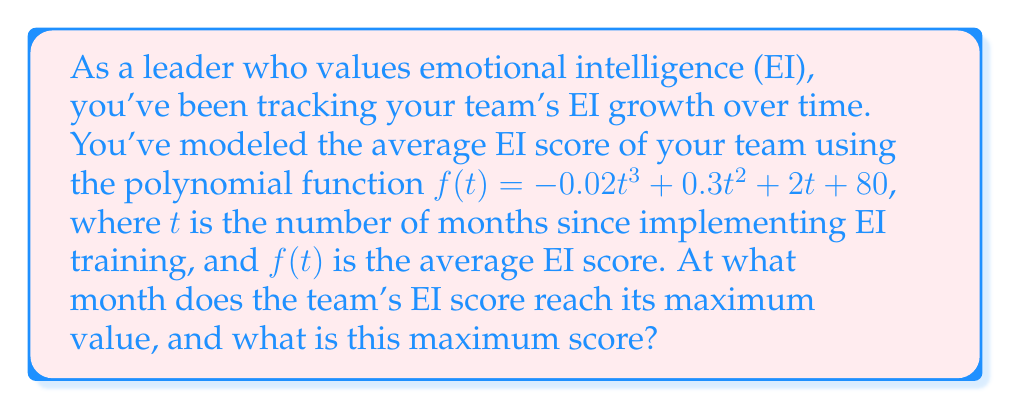Help me with this question. To find the maximum value of the function, we need to follow these steps:

1) First, we need to find the derivative of the function:
   $$f'(t) = -0.06t^2 + 0.6t + 2$$

2) To find the critical points, we set the derivative equal to zero and solve:
   $$-0.06t^2 + 0.6t + 2 = 0$$

3) This is a quadratic equation. We can solve it using the quadratic formula:
   $$t = \frac{-b \pm \sqrt{b^2 - 4ac}}{2a}$$
   where $a = -0.06$, $b = 0.6$, and $c = 2$

4) Plugging in these values:
   $$t = \frac{-0.6 \pm \sqrt{0.6^2 - 4(-0.06)(2)}}{2(-0.06)}$$
   $$= \frac{-0.6 \pm \sqrt{0.36 + 0.48}}{-0.12}$$
   $$= \frac{-0.6 \pm \sqrt{0.84}}{-0.12}$$
   $$= \frac{-0.6 \pm 0.9165}{-0.12}$$

5) This gives us two solutions:
   $$t_1 = \frac{-0.6 + 0.9165}{-0.12} \approx 2.64$$
   $$t_2 = \frac{-0.6 - 0.9165}{-0.12} \approx 12.64$$

6) To determine which of these is the maximum, we can check the second derivative:
   $$f''(t) = -0.12t + 0.6$$
   
   At $t = 2.64$: $f''(2.64) = -0.12(2.64) + 0.6 = 0.2832 > 0$
   At $t = 12.64$: $f''(12.64) = -0.12(12.64) + 0.6 = -0.9168 < 0$

   Since $f''(12.64) < 0$, this is the maximum point.

7) The maximum occurs at approximately 12.64 months. Since we're dealing with months, we round this to 13 months.

8) To find the maximum score, we plug t = 13 into our original function:
   $$f(13) = -0.02(13)^3 + 0.3(13)^2 + 2(13) + 80$$
   $$= -0.02(2197) + 0.3(169) + 26 + 80$$
   $$= -43.94 + 50.7 + 26 + 80$$
   $$= 112.76$$

9) Rounding to the nearest whole number (as EI scores are typically integers), we get 113.
Answer: The team's EI score reaches its maximum after 13 months, with a maximum score of 113. 